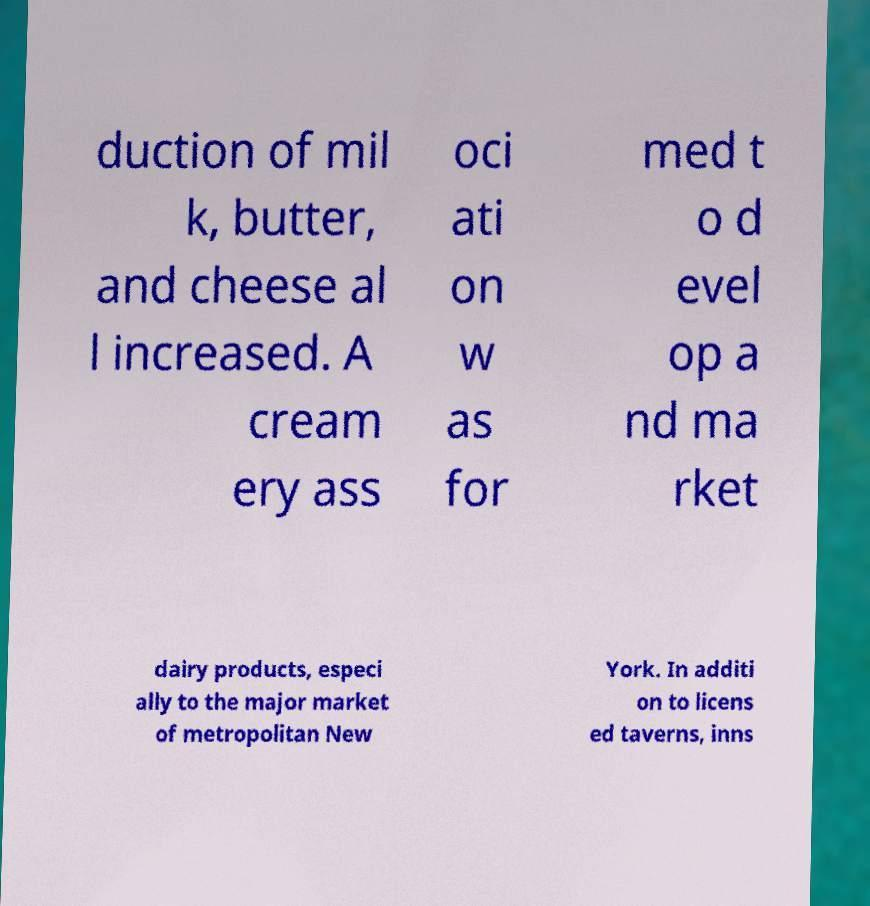There's text embedded in this image that I need extracted. Can you transcribe it verbatim? duction of mil k, butter, and cheese al l increased. A cream ery ass oci ati on w as for med t o d evel op a nd ma rket dairy products, especi ally to the major market of metropolitan New York. In additi on to licens ed taverns, inns 